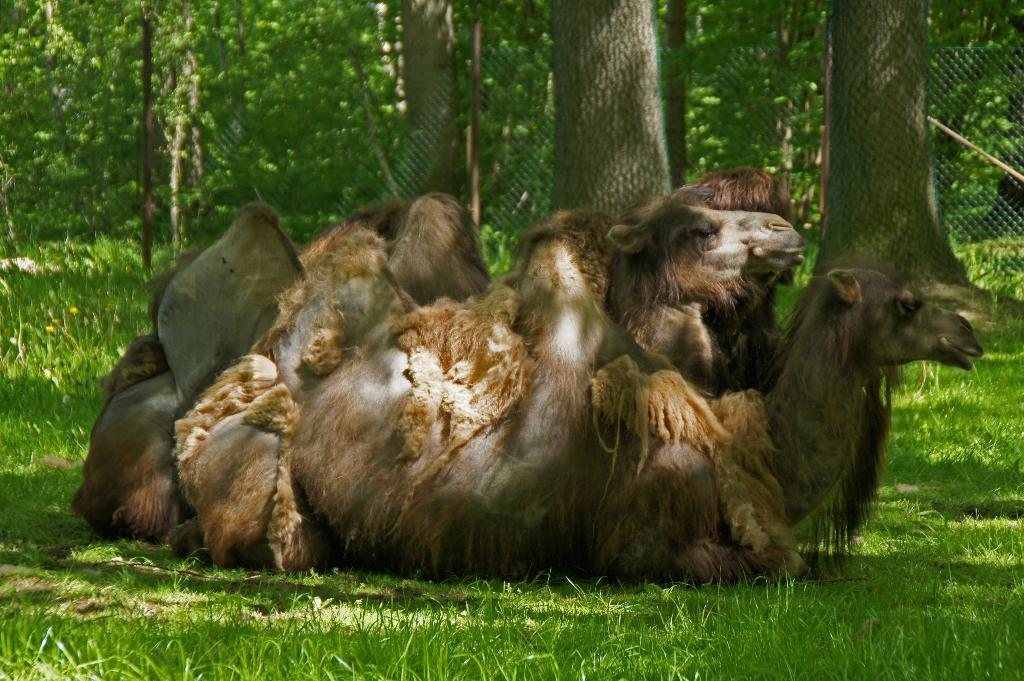What animals are in the center of the image? There are camels in the center of the image. What type of vegetation is at the bottom of the image? There is grass at the bottom of the image. What can be seen in the background of the image? There is fencing and trees in the background of the image. What type of can is being used by the camels in the image? There is no can present in the image, as it features camels, grass, fencing, and trees. 